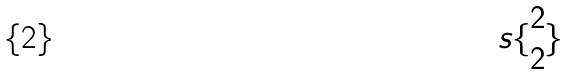<formula> <loc_0><loc_0><loc_500><loc_500>s \{ \begin{matrix} 2 \\ 2 \end{matrix} \}</formula> 